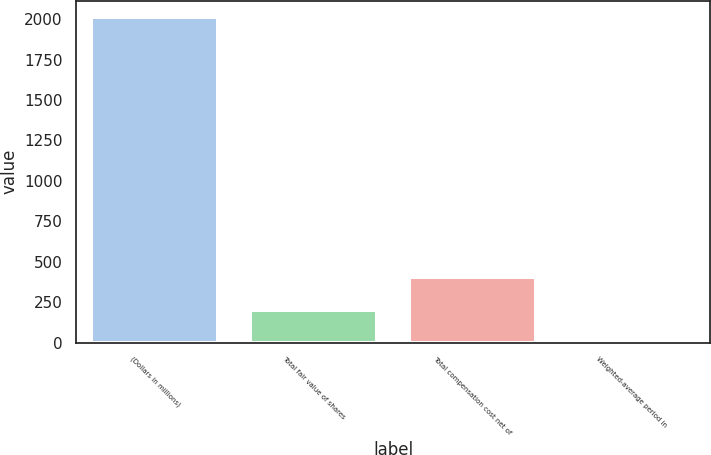<chart> <loc_0><loc_0><loc_500><loc_500><bar_chart><fcel>(Dollars in millions)<fcel>Total fair value of shares<fcel>Total compensation cost net of<fcel>Weighted-average period in<nl><fcel>2012<fcel>203.9<fcel>404.8<fcel>3<nl></chart> 